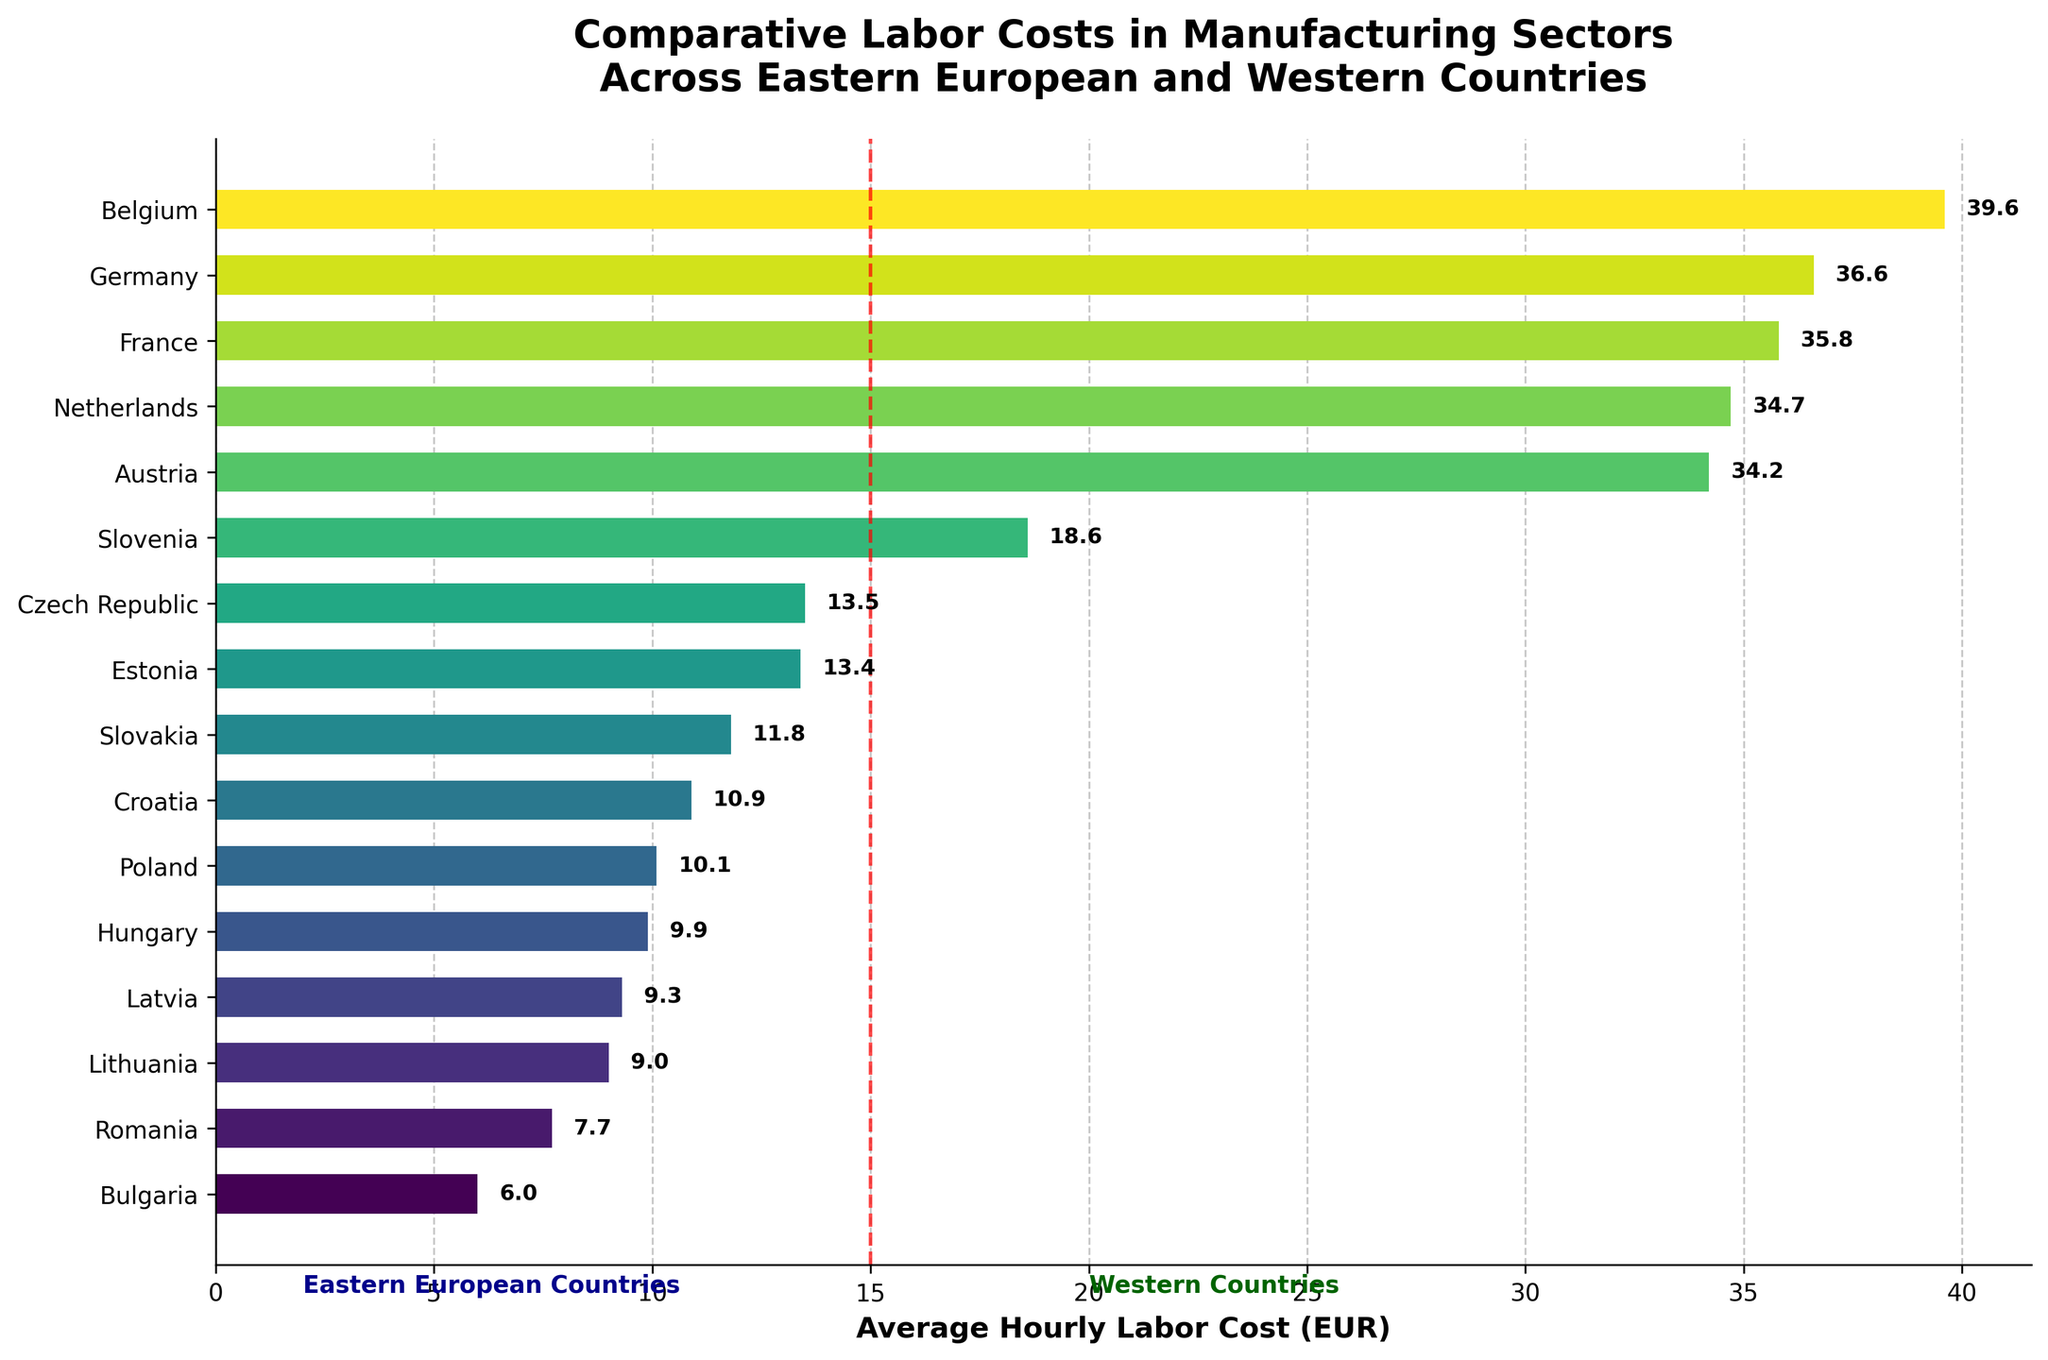What's the country with the lowest labor cost? Observing the bar chart, the country with the shortest bar represents the lowest labor cost, which is Bulgaria with 6.0 EUR.
Answer: Bulgaria Which country has the highest labor cost among Eastern European countries? The longest bar among the first seven countries on the y-axis represents the highest labor cost among Eastern European countries, which is Slovenia with 18.6 EUR.
Answer: Slovenia How much greater is Belgium's labor cost compared to Poland's? Belgium's labor cost is 39.6 EUR, and Poland's is 10.1 EUR. The difference is calculated as 39.6 - 10.1 = 29.5 EUR.
Answer: 29.5 EUR What is the average labor cost for Western countries shown in the figure? Western countries have labor costs as follows: Germany (36.6), France (35.8), Netherlands (34.7), Austria (34.2), and Belgium (39.6). Their average labor cost is (36.6 + 35.8 + 34.7 + 34.2 + 39.6) / 5 = 36.2 EUR.
Answer: 36.2 EUR Which Eastern European country has a labor cost closest to that of Estonia? Estonia has a labor cost of 13.4 EUR. Among other Eastern European countries, Czech Republic has the closest labor cost of 13.5 EUR.
Answer: Czech Republic Which two countries have the smallest difference in their labor costs, and what is the difference? Observing the closeness of the bars, Czech Republic and Estonia have labor costs of 13.5 EUR and 13.4 EUR, respectively. The difference is 13.5 - 13.4 = 0.1 EUR.
Answer: Czech Republic & Estonia, 0.1 EUR How many countries have labor costs greater than 30 EUR? Counting the bars with labor costs exceeding 30 EUR: Germany, France, Netherlands, Austria, and Belgium, there are 5 such countries.
Answer: 5 Identify the country with the median labor cost in the dataset. To find the median, we need to order the labor costs and find the middle value(s). Here, we sort the labor costs and find the median is between Austria (34.2) and Netherlands (34.7) based on the position.
Answer: Netherlands What is the approximate range of labor costs among Eastern European countries? The range is the difference between the highest and lowest labor costs in the Eastern European countries. Highest: Slovenia (18.6 EUR), lowest: Bulgaria (6.0 EUR). Therefore, the range is 18.6 - 6.0 = 12.6 EUR.
Answer: 12.6 EUR 